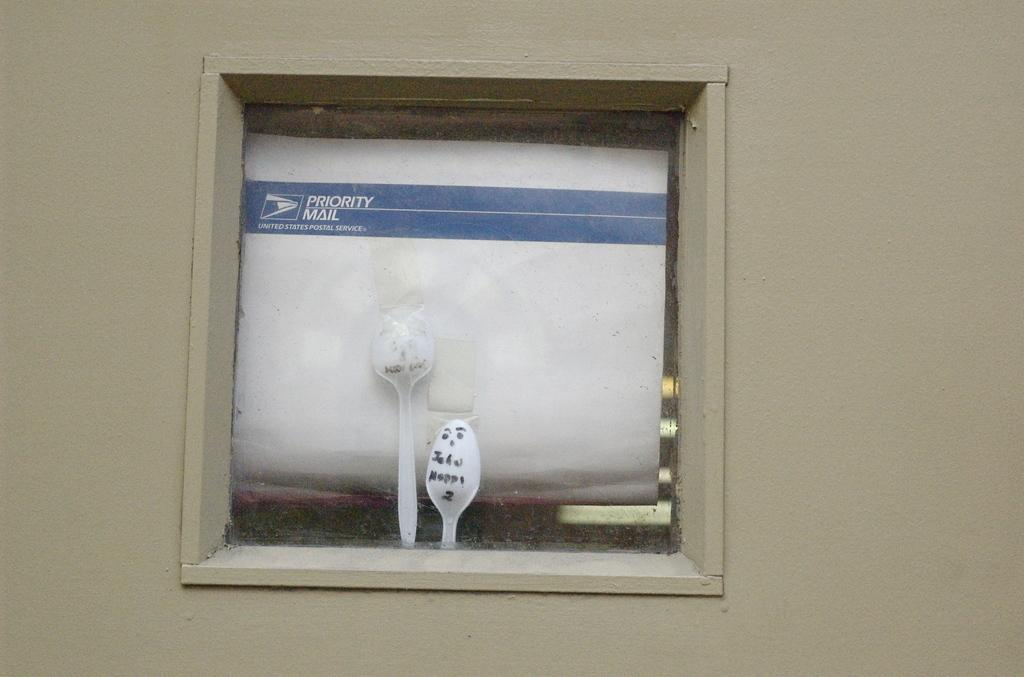What is the design of the door in the image? The door has a glass panel in the middle. What can be seen through the glass panel? There are two spoons and a paper with writing on it on the other side of the glass. What type of pot is visible on the other side of the glass? There is no pot visible on the other side of the glass in the image. Can you tell me how many ants are crawling on the paper with writing? There are no ants present in the image; only the two spoons and the paper with writing can be seen on the other side of the glass. 